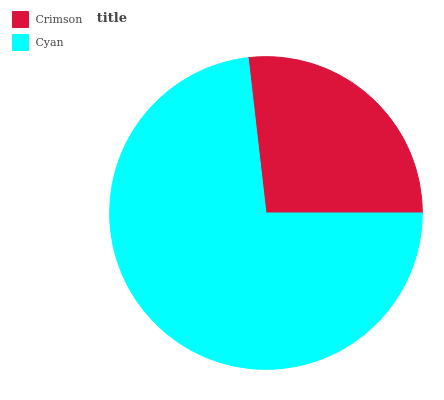Is Crimson the minimum?
Answer yes or no. Yes. Is Cyan the maximum?
Answer yes or no. Yes. Is Cyan the minimum?
Answer yes or no. No. Is Cyan greater than Crimson?
Answer yes or no. Yes. Is Crimson less than Cyan?
Answer yes or no. Yes. Is Crimson greater than Cyan?
Answer yes or no. No. Is Cyan less than Crimson?
Answer yes or no. No. Is Cyan the high median?
Answer yes or no. Yes. Is Crimson the low median?
Answer yes or no. Yes. Is Crimson the high median?
Answer yes or no. No. Is Cyan the low median?
Answer yes or no. No. 